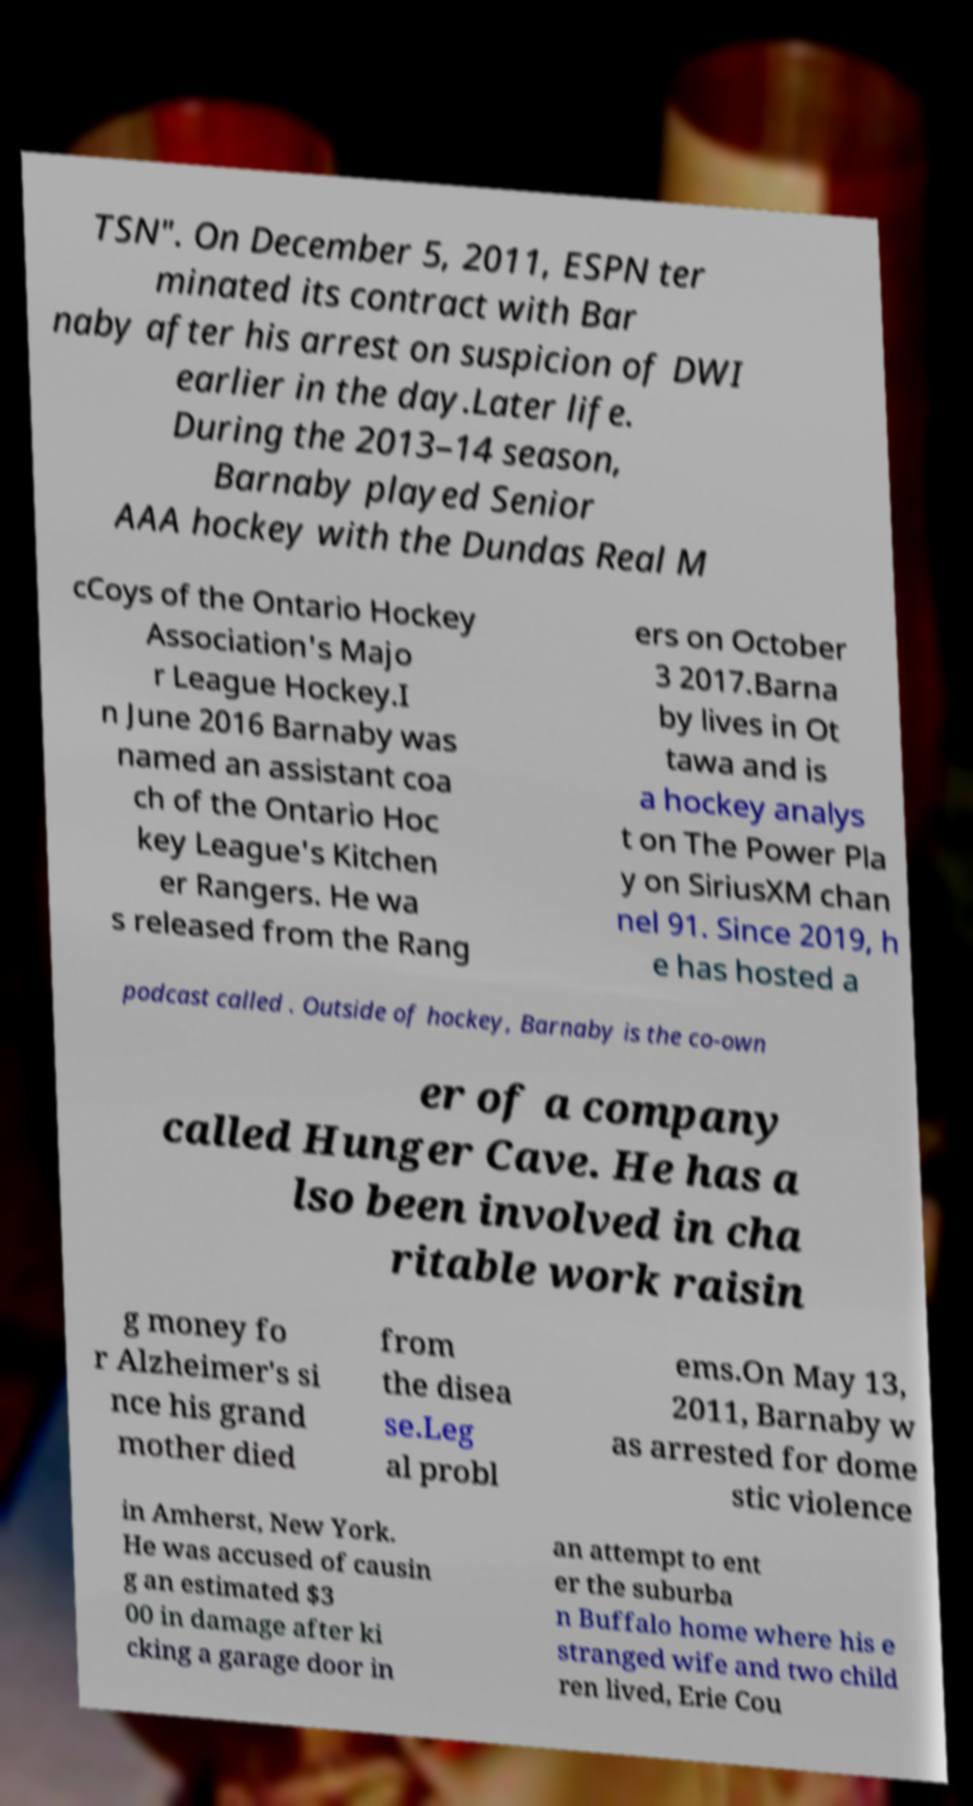Could you extract and type out the text from this image? TSN". On December 5, 2011, ESPN ter minated its contract with Bar naby after his arrest on suspicion of DWI earlier in the day.Later life. During the 2013–14 season, Barnaby played Senior AAA hockey with the Dundas Real M cCoys of the Ontario Hockey Association's Majo r League Hockey.I n June 2016 Barnaby was named an assistant coa ch of the Ontario Hoc key League's Kitchen er Rangers. He wa s released from the Rang ers on October 3 2017.Barna by lives in Ot tawa and is a hockey analys t on The Power Pla y on SiriusXM chan nel 91. Since 2019, h e has hosted a podcast called . Outside of hockey, Barnaby is the co-own er of a company called Hunger Cave. He has a lso been involved in cha ritable work raisin g money fo r Alzheimer's si nce his grand mother died from the disea se.Leg al probl ems.On May 13, 2011, Barnaby w as arrested for dome stic violence in Amherst, New York. He was accused of causin g an estimated $3 00 in damage after ki cking a garage door in an attempt to ent er the suburba n Buffalo home where his e stranged wife and two child ren lived, Erie Cou 